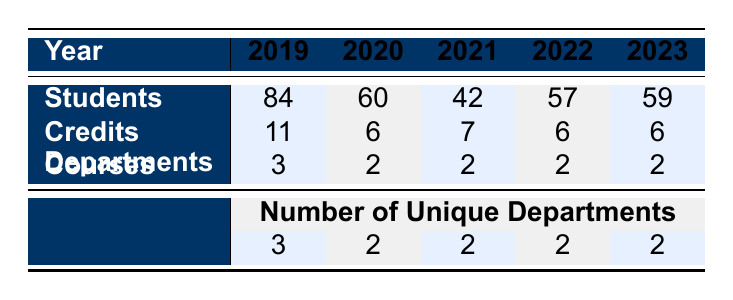What is the total number of students enrolled over the years? To find the total number of students, we sum the values from the "Students" row: 84 (2019) + 60 (2020) + 42 (2021) + 57 (2022) + 59 (2023) = 302.
Answer: 302 Which year had the highest number of students enrolled? From the "Students" row, the highest value is 84 in 2019.
Answer: 2019 How many unique departments are represented in the data overall? The table shows the number of unique departments for each year. The maximum observed value is 3 (in 2019), so there are 3 unique departments overall.
Answer: 3 How many total credits were offered across all years? To find the total credits, we sum the values from the "Credits" row: 11 (2019) + 6 (2020) + 7 (2021) + 6 (2022) + 6 (2023) = 36.
Answer: 36 Is there a year where the number of students decreased compared to the previous year? By comparing the "Students" row year by year: 2019 to 2020 (decrease), 2020 to 2021 (decrease), 2021 to 2022 (increase), and 2022 to 2023 (increase), we see a decrease in 2020 and 2021.
Answer: Yes Which year had the least amount of credits offered? Looking at the "Credits" row, the least value is 6, which was seen in 2020, 2022, and 2023.
Answer: 2020, 2022, 2023 How many different courses were offered in total? The "Courses" row shows that all years have 2 courses each, except 2019 with 3 courses. Total courses = (3) + (2) * 4 = 11.
Answer: 11 Did the total number of courses remain consistent in recent years? The "Courses" row shows values of 3, 2, 2, 2, 2, which indicates a decrease from 2019 to the following years, so the total number of courses did not remain consistent.
Answer: No What was the average number of students per course in 2022? In 2022, there were 57 students across 2 courses, so the average is 57 / 2 = 28.5.
Answer: 28.5 